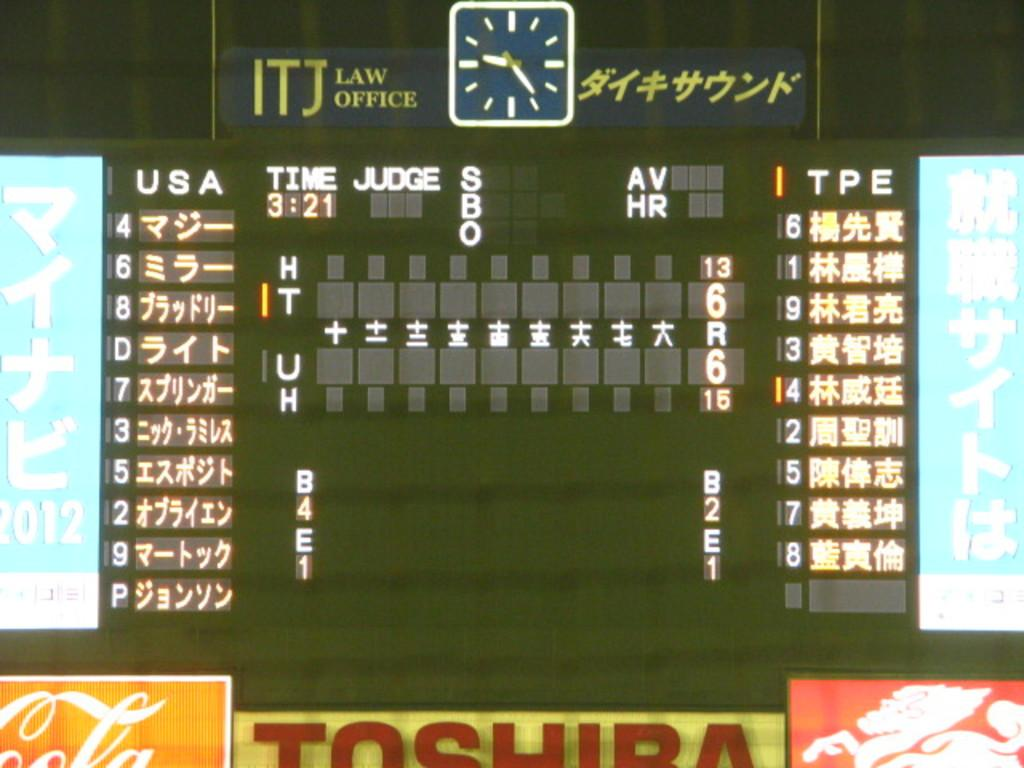<image>
Present a compact description of the photo's key features. Number 4 is leading off for the USA team. 